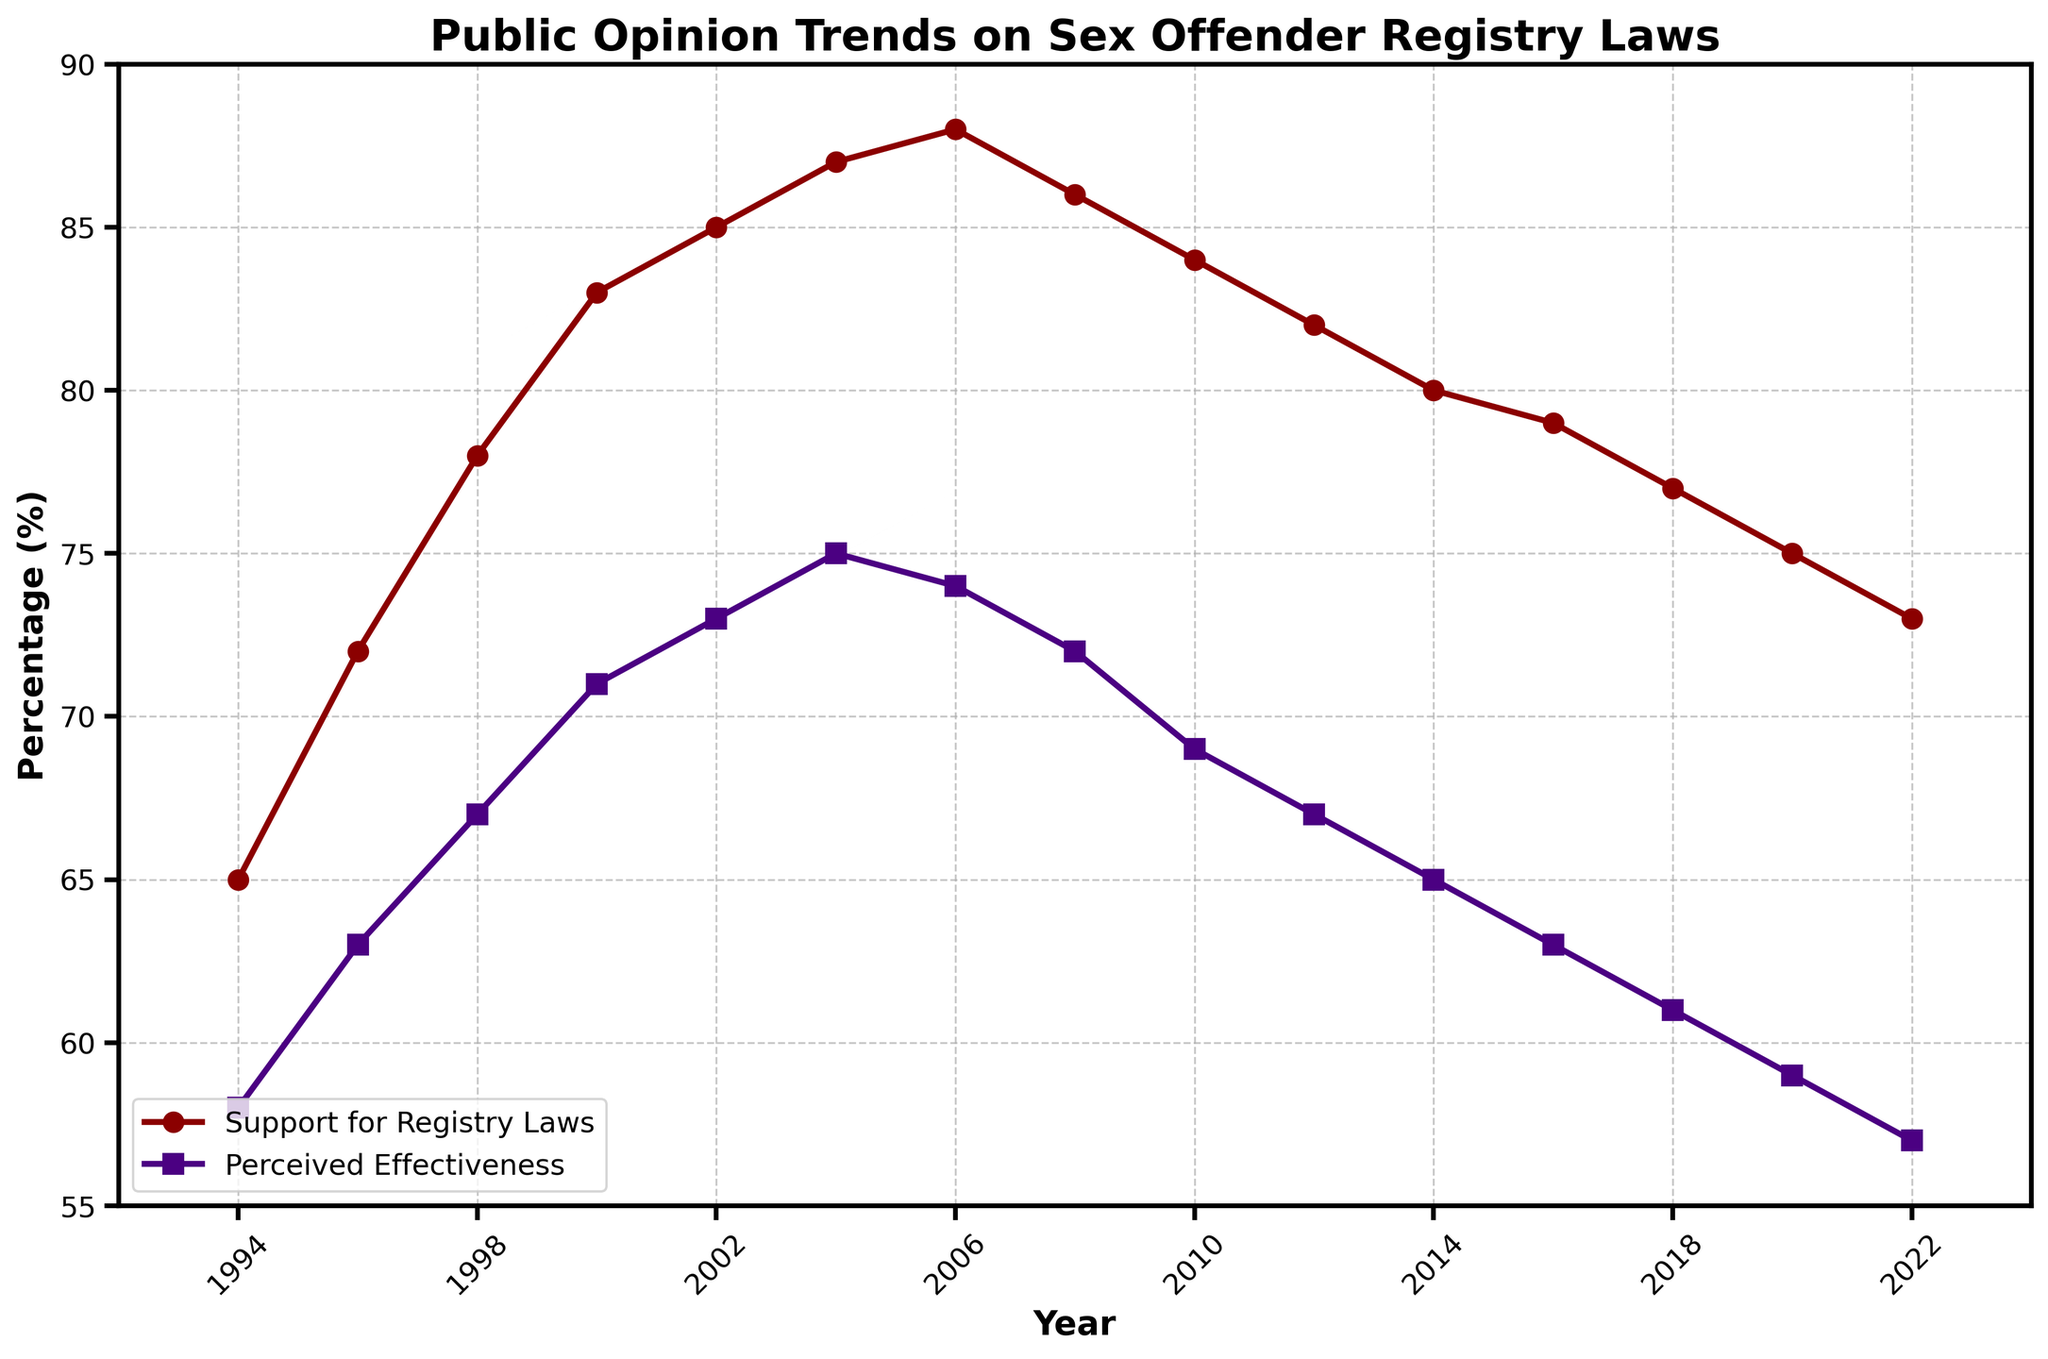What is the trend of public support for sex offender registry laws from 1994 to 2022? From the figure, the public support for registry laws shows a general increasing trend from 1994 to 2006, peaking at 88%, followed by a gradual decline until 2022, where it is 73%.
Answer: Increasing until 2006, then decreasing How does the perceived effectiveness compare to the support for registry laws in the year 2000? In 2000, the support for registry laws is 83%, while the perceived effectiveness is 71%. The support is higher than the perceived effectiveness by 12%.
Answer: Support is 12% higher Which year showed the highest level of public support for registry laws? The figure indicates that 2006 has the highest level of public support for registry laws at 88%.
Answer: 2006 By how many percentage points did the perceived effectiveness of registry laws decrease between 2006 and 2022? The perceived effectiveness in 2006 was 74%, and it decreased to 57% in 2022. The difference is 74% - 57% = 17% points.
Answer: 17 percentage points What are the visual markers used to differentiate between the two plotted lines in the figure? The figure uses circles ("o") for the support for registry laws line and squares ("s") for the perceived effectiveness line. The support line is red and the effectiveness line is indigo.
Answer: Circles for support, squares for effectiveness; red and indigo Between which consecutive years did the perceived effectiveness show the largest drop? The largest drop in perceived effectiveness occurred between 2010 (69%) and 2012 (67%), which is a decrease of 2%.
Answer: 2010 to 2012 Compare the overall trends of support and perceived effectiveness: Did they both peak at the same year? The overall trends show that both support and perceived effectiveness do not peak at the same year. Support peaked in 2006, while perceived effectiveness peaked in 2006 as well but continued to drop more rapidly after that.
Answer: No, they did not peak at the same year What is the approximate average percentage of public support for all the years combined? Sum the percentages for support for all years and divide by the total number of years. (65 + 72 + 78 + 83 + 85 + 87 + 88 + 86 + 84 + 82 + 80 + 79 + 77 + 75 + 73) / 15 = 80.2%.
Answer: 80.2% In 1998, by what ratio does the public support for registry laws exceed the perceived effectiveness? In 1998, the support is 78% and effectiveness is 67%. The ratio is 78/67 which simplifies to approximately 1.16.
Answer: Approximately 1.16 What does the general trend from 1994 to 2022 suggest about public trust in the effectiveness of registry laws? The trend shows that initial trust in the effectiveness increased slightly until 2006, but then declined steadily, indicating a growing public skepticism about their effectiveness over time.
Answer: Increasing skepticism 